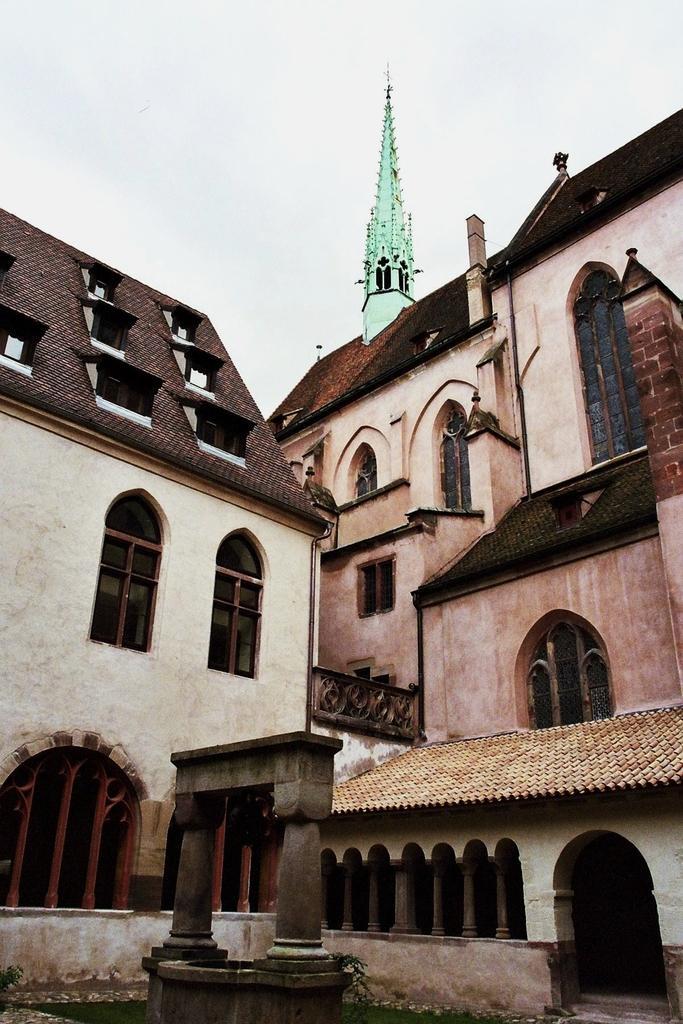Can you describe this image briefly? This is the picture of a place where we have two buildings to which there are some windows, arches and some other things around. 